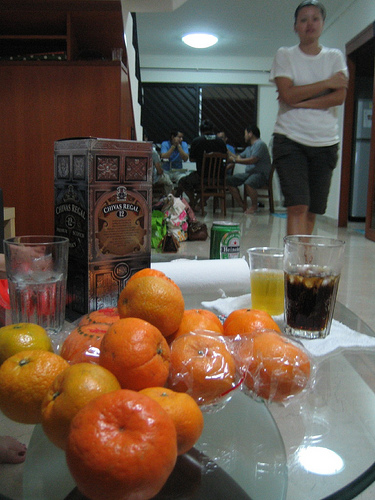Can you infer anything about the location based on the items and the setting? The presence of a box of Costa Rican coffee and the style of the furniture may hint at a Central American setting, possibly inside a home. The informal arrangement of snacks and drinks on the table, along with the communal seating in the background, suggests a relaxed, domestic environment. 